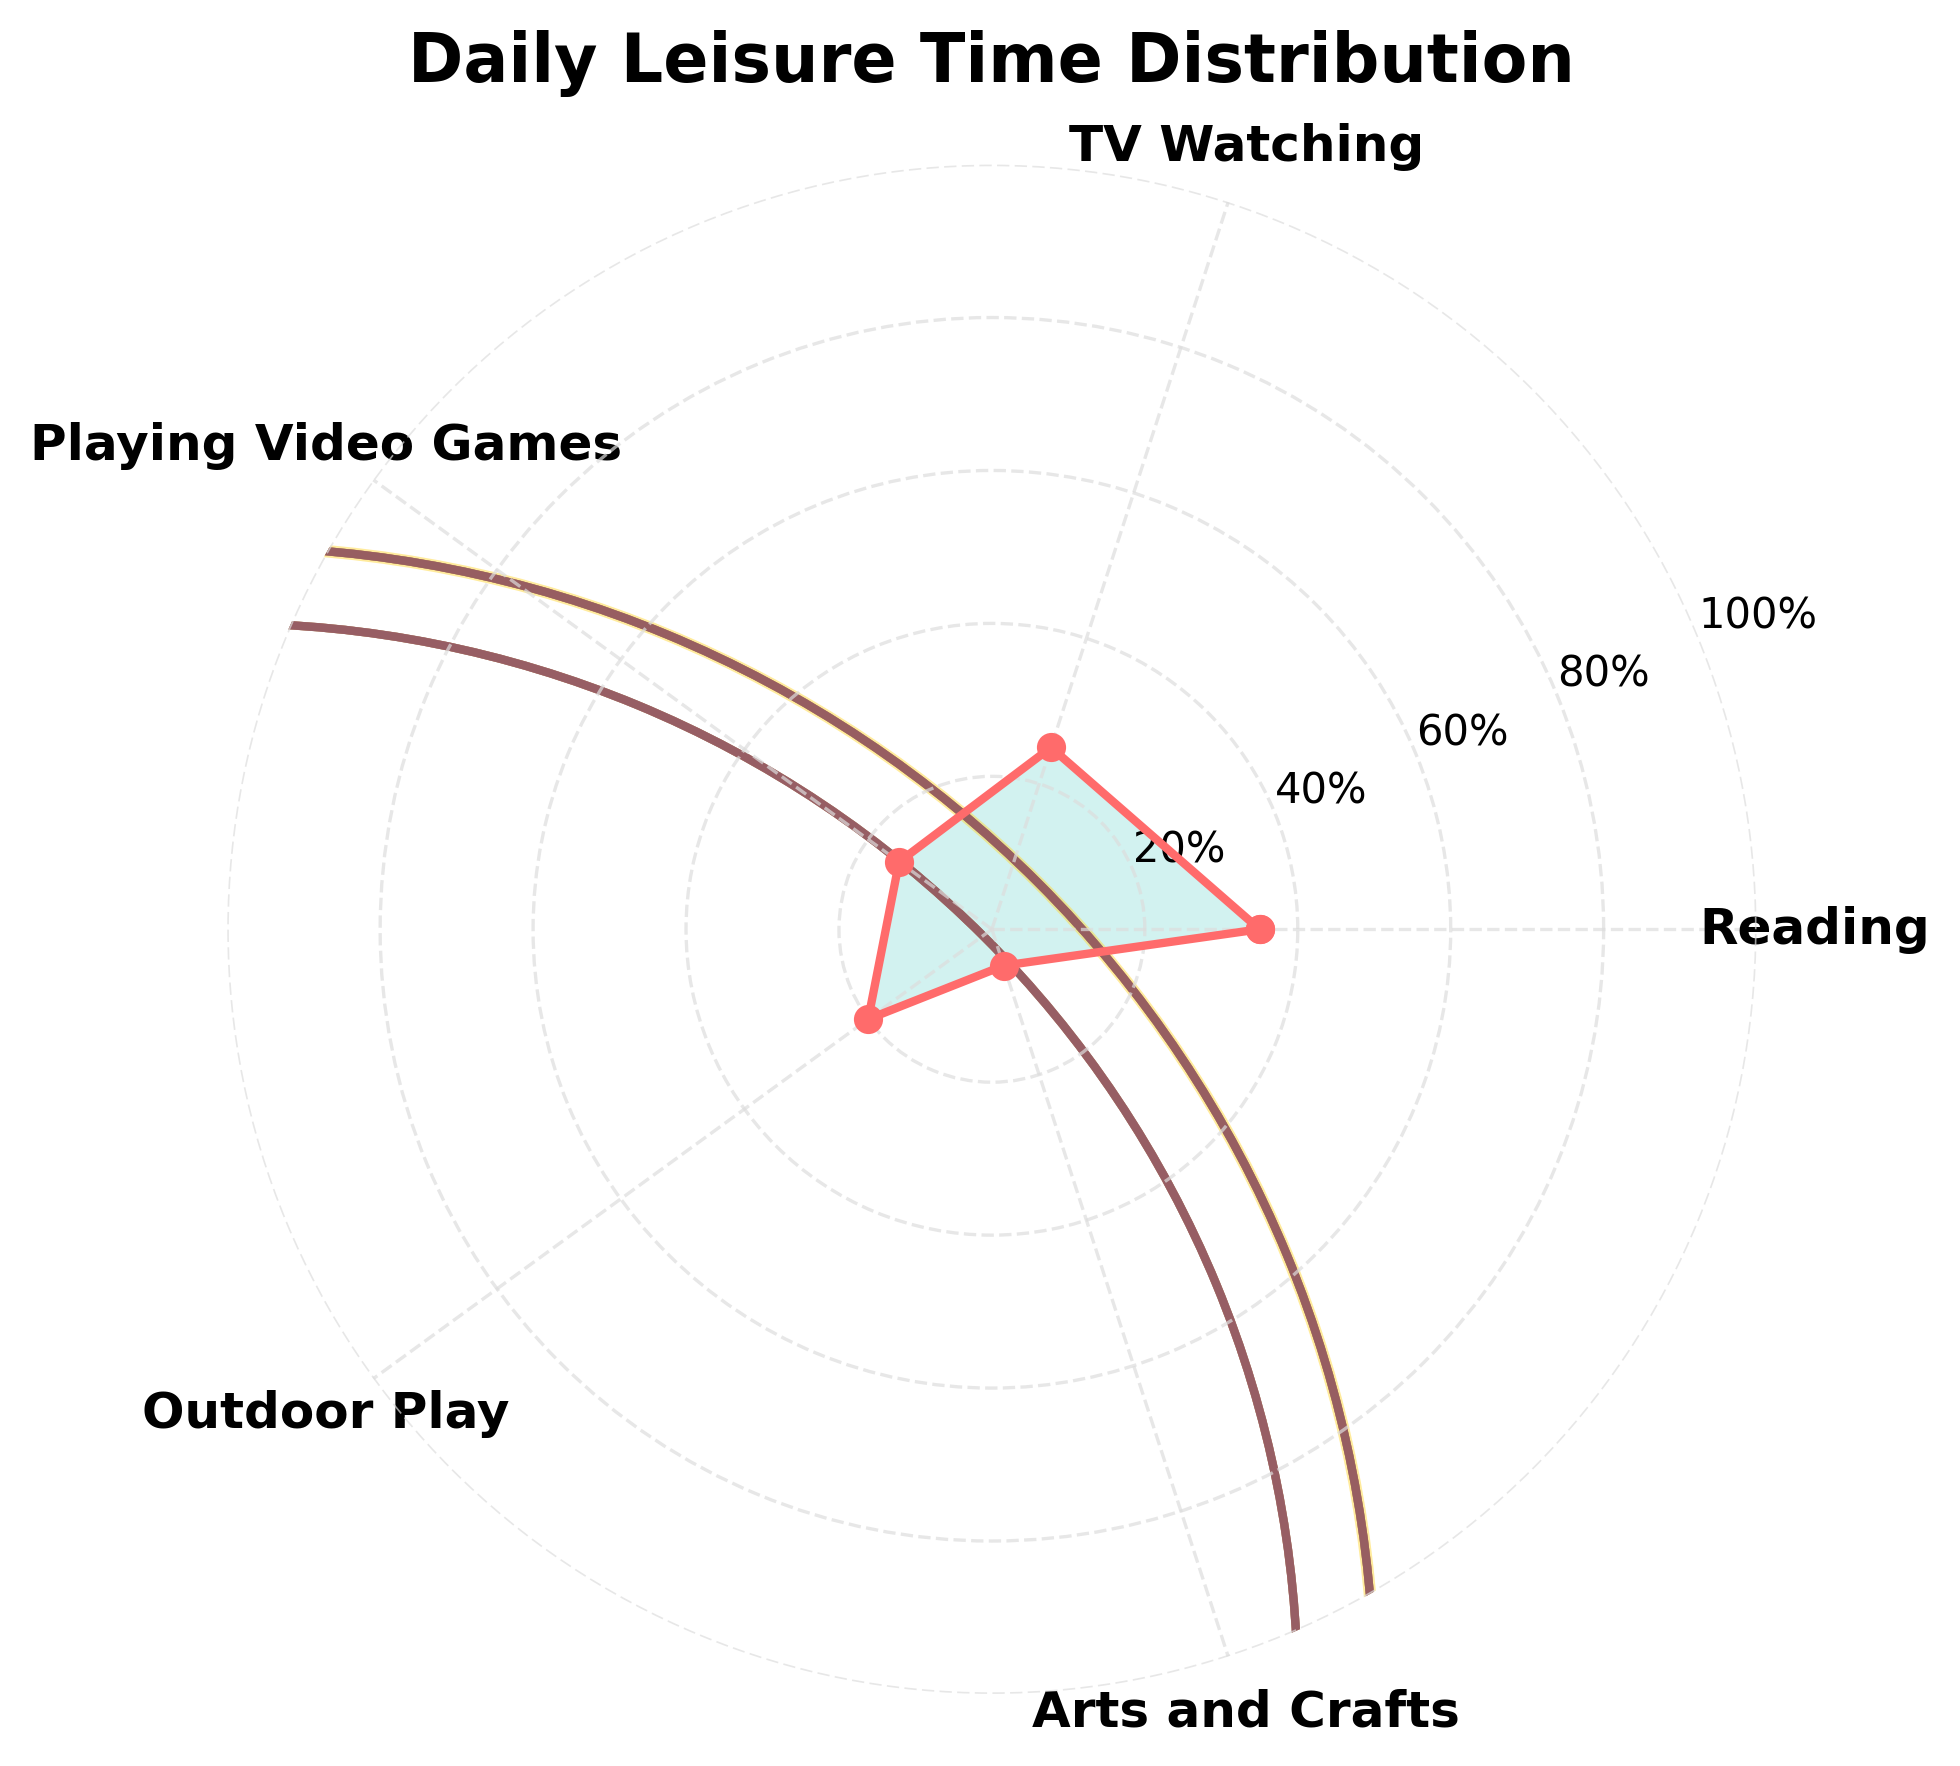What's the title of the figure? The title of the figure is displayed at the top and reads "Daily Leisure Time Distribution".
Answer: Daily Leisure Time Distribution What are the five activities listed in the figure? The activities are marked around the polar plot, visible as the axis labels. They are "Reading", "TV Watching", "Playing Video Games", "Outdoor Play", and "Arts and Crafts".
Answer: Reading, TV Watching, Playing Video Games, Outdoor Play, Arts and Crafts Which activity occupies the largest portion of daily leisure time? By comparing the percentage labels around the polar plot, we see that "Reading" has the highest percentage at 35%.
Answer: Reading What percent of daily leisure time is spent on watching TV and playing video games combined? Watching TV accounts for 25% and playing video games accounts for 15%. Adding these values gives 25% + 15% = 40%.
Answer: 40% Which activity has the smallest portion in the daily leisure time distribution? Comparing the percentages, "Arts and Crafts" has the lowest percentage at 5%.
Answer: Arts and Crafts How much more time is spent on reading compared to outdoor play? Reading takes up 35% and outdoor play takes up 20%. The difference is 35% - 20% = 15%.
Answer: 15% What is the average percentage of time spent on TV Watching, Playing Video Games, and Arts and Crafts together? Summing their percentages: 25% (TV Watching) + 15% (Playing Video Games) + 5% (Arts and Crafts) = 45%. Dividing by 3 gives the average: 45% / 3 = 15%.
Answer: 15% Is more time spent on watching TV than playing video games and doing arts and crafts combined? Watching TV occupies 25%, while playing video games and doing arts and crafts together is 15% + 5% = 20%. Since 25% > 20%, more time is indeed spent on watching TV.
Answer: Yes What is the total proportion of time spent on activities other than reading? Total percentage for other activities: 25% (TV Watching) + 15% (Playing Video Games) + 20% (Outdoor Play) + 5% (Arts and Crafts) = 65%.
Answer: 65% If a child has 4 hours of leisure time in a day, how much time is spent reading? Since reading accounts for 35%, multiply this by 4 hours: 35/100 * 4 = 1.4 hours.
Answer: 1.4 hours 